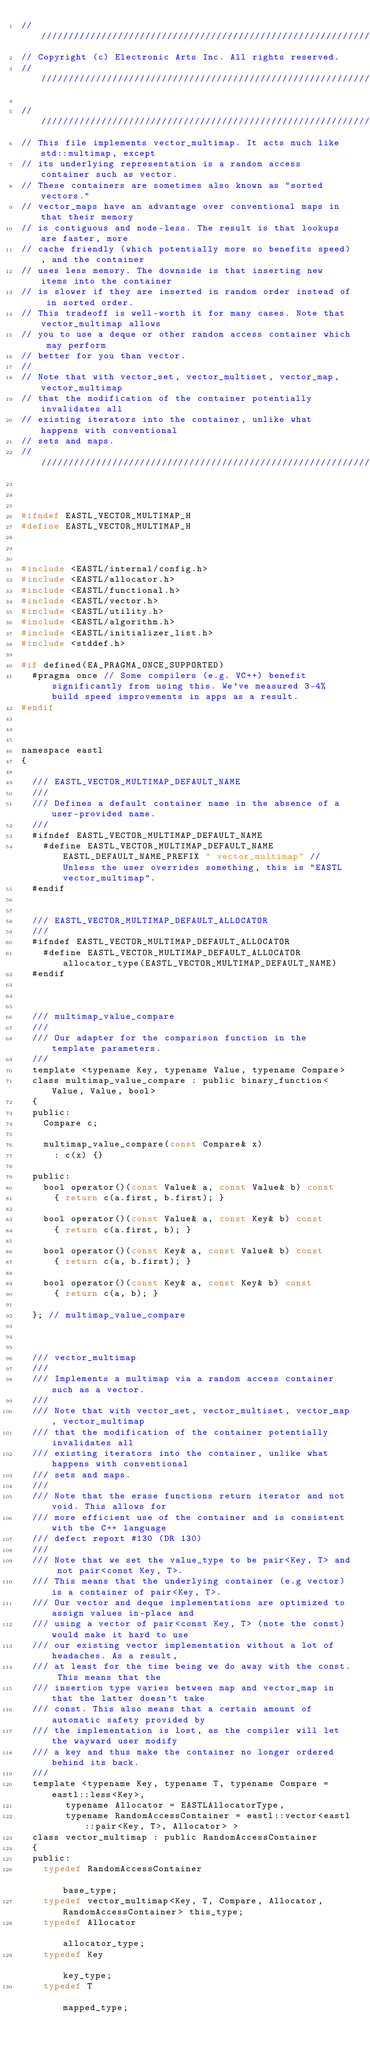<code> <loc_0><loc_0><loc_500><loc_500><_C_>///////////////////////////////////////////////////////////////////////////////
// Copyright (c) Electronic Arts Inc. All rights reserved.
//////////////////////////////////////////////////////////////////////////////

//////////////////////////////////////////////////////////////////////////////
// This file implements vector_multimap. It acts much like std::multimap, except 
// its underlying representation is a random access container such as vector. 
// These containers are sometimes also known as "sorted vectors."  
// vector_maps have an advantage over conventional maps in that their memory
// is contiguous and node-less. The result is that lookups are faster, more 
// cache friendly (which potentially more so benefits speed), and the container
// uses less memory. The downside is that inserting new items into the container
// is slower if they are inserted in random order instead of in sorted order.
// This tradeoff is well-worth it for many cases. Note that vector_multimap allows
// you to use a deque or other random access container which may perform
// better for you than vector.
//
// Note that with vector_set, vector_multiset, vector_map, vector_multimap
// that the modification of the container potentially invalidates all 
// existing iterators into the container, unlike what happens with conventional
// sets and maps.
//////////////////////////////////////////////////////////////////////////////



#ifndef EASTL_VECTOR_MULTIMAP_H
#define EASTL_VECTOR_MULTIMAP_H



#include <EASTL/internal/config.h>
#include <EASTL/allocator.h>
#include <EASTL/functional.h>
#include <EASTL/vector.h>
#include <EASTL/utility.h>
#include <EASTL/algorithm.h>
#include <EASTL/initializer_list.h>
#include <stddef.h>

#if defined(EA_PRAGMA_ONCE_SUPPORTED)
	#pragma once // Some compilers (e.g. VC++) benefit significantly from using this. We've measured 3-4% build speed improvements in apps as a result.
#endif



namespace eastl
{

	/// EASTL_VECTOR_MULTIMAP_DEFAULT_NAME
	///
	/// Defines a default container name in the absence of a user-provided name.
	///
	#ifndef EASTL_VECTOR_MULTIMAP_DEFAULT_NAME
		#define EASTL_VECTOR_MULTIMAP_DEFAULT_NAME EASTL_DEFAULT_NAME_PREFIX " vector_multimap" // Unless the user overrides something, this is "EASTL vector_multimap".
	#endif


	/// EASTL_VECTOR_MULTIMAP_DEFAULT_ALLOCATOR
	///
	#ifndef EASTL_VECTOR_MULTIMAP_DEFAULT_ALLOCATOR
		#define EASTL_VECTOR_MULTIMAP_DEFAULT_ALLOCATOR allocator_type(EASTL_VECTOR_MULTIMAP_DEFAULT_NAME)
	#endif



	/// multimap_value_compare
	///
	/// Our adapter for the comparison function in the template parameters.
	///
	template <typename Key, typename Value, typename Compare>
	class multimap_value_compare : public binary_function<Value, Value, bool>
	{
	public:
		Compare c;

		multimap_value_compare(const Compare& x)
			: c(x) {}

	public:
		bool operator()(const Value& a, const Value& b) const
			{ return c(a.first, b.first); }

		bool operator()(const Value& a, const Key& b) const
			{ return c(a.first, b); }

		bool operator()(const Key& a, const Value& b) const
			{ return c(a, b.first); }

		bool operator()(const Key& a, const Key& b) const
			{ return c(a, b); }

	}; // multimap_value_compare



	/// vector_multimap
	///
	/// Implements a multimap via a random access container such as a vector.
	///
	/// Note that with vector_set, vector_multiset, vector_map, vector_multimap
	/// that the modification of the container potentially invalidates all 
	/// existing iterators into the container, unlike what happens with conventional
	/// sets and maps.
	///
	/// Note that the erase functions return iterator and not void. This allows for 
	/// more efficient use of the container and is consistent with the C++ language 
	/// defect report #130 (DR 130)
	///
	/// Note that we set the value_type to be pair<Key, T> and not pair<const Key, T>.
	/// This means that the underlying container (e.g vector) is a container of pair<Key, T>.
	/// Our vector and deque implementations are optimized to assign values in-place and 
	/// using a vector of pair<const Key, T> (note the const) would make it hard to use
	/// our existing vector implementation without a lot of headaches. As a result, 
	/// at least for the time being we do away with the const. This means that the 
	/// insertion type varies between map and vector_map in that the latter doesn't take
	/// const. This also means that a certain amount of automatic safety provided by 
	/// the implementation is lost, as the compiler will let the wayward user modify 
	/// a key and thus make the container no longer ordered behind its back.
	///
	template <typename Key, typename T, typename Compare = eastl::less<Key>, 
			  typename Allocator = EASTLAllocatorType,
			  typename RandomAccessContainer = eastl::vector<eastl::pair<Key, T>, Allocator> >
	class vector_multimap : public RandomAccessContainer
	{
	public:
		typedef RandomAccessContainer                                              base_type;
		typedef vector_multimap<Key, T, Compare, Allocator, RandomAccessContainer> this_type;
		typedef Allocator                                                          allocator_type;
		typedef Key                                                                key_type;
		typedef T                                                                  mapped_type;</code> 